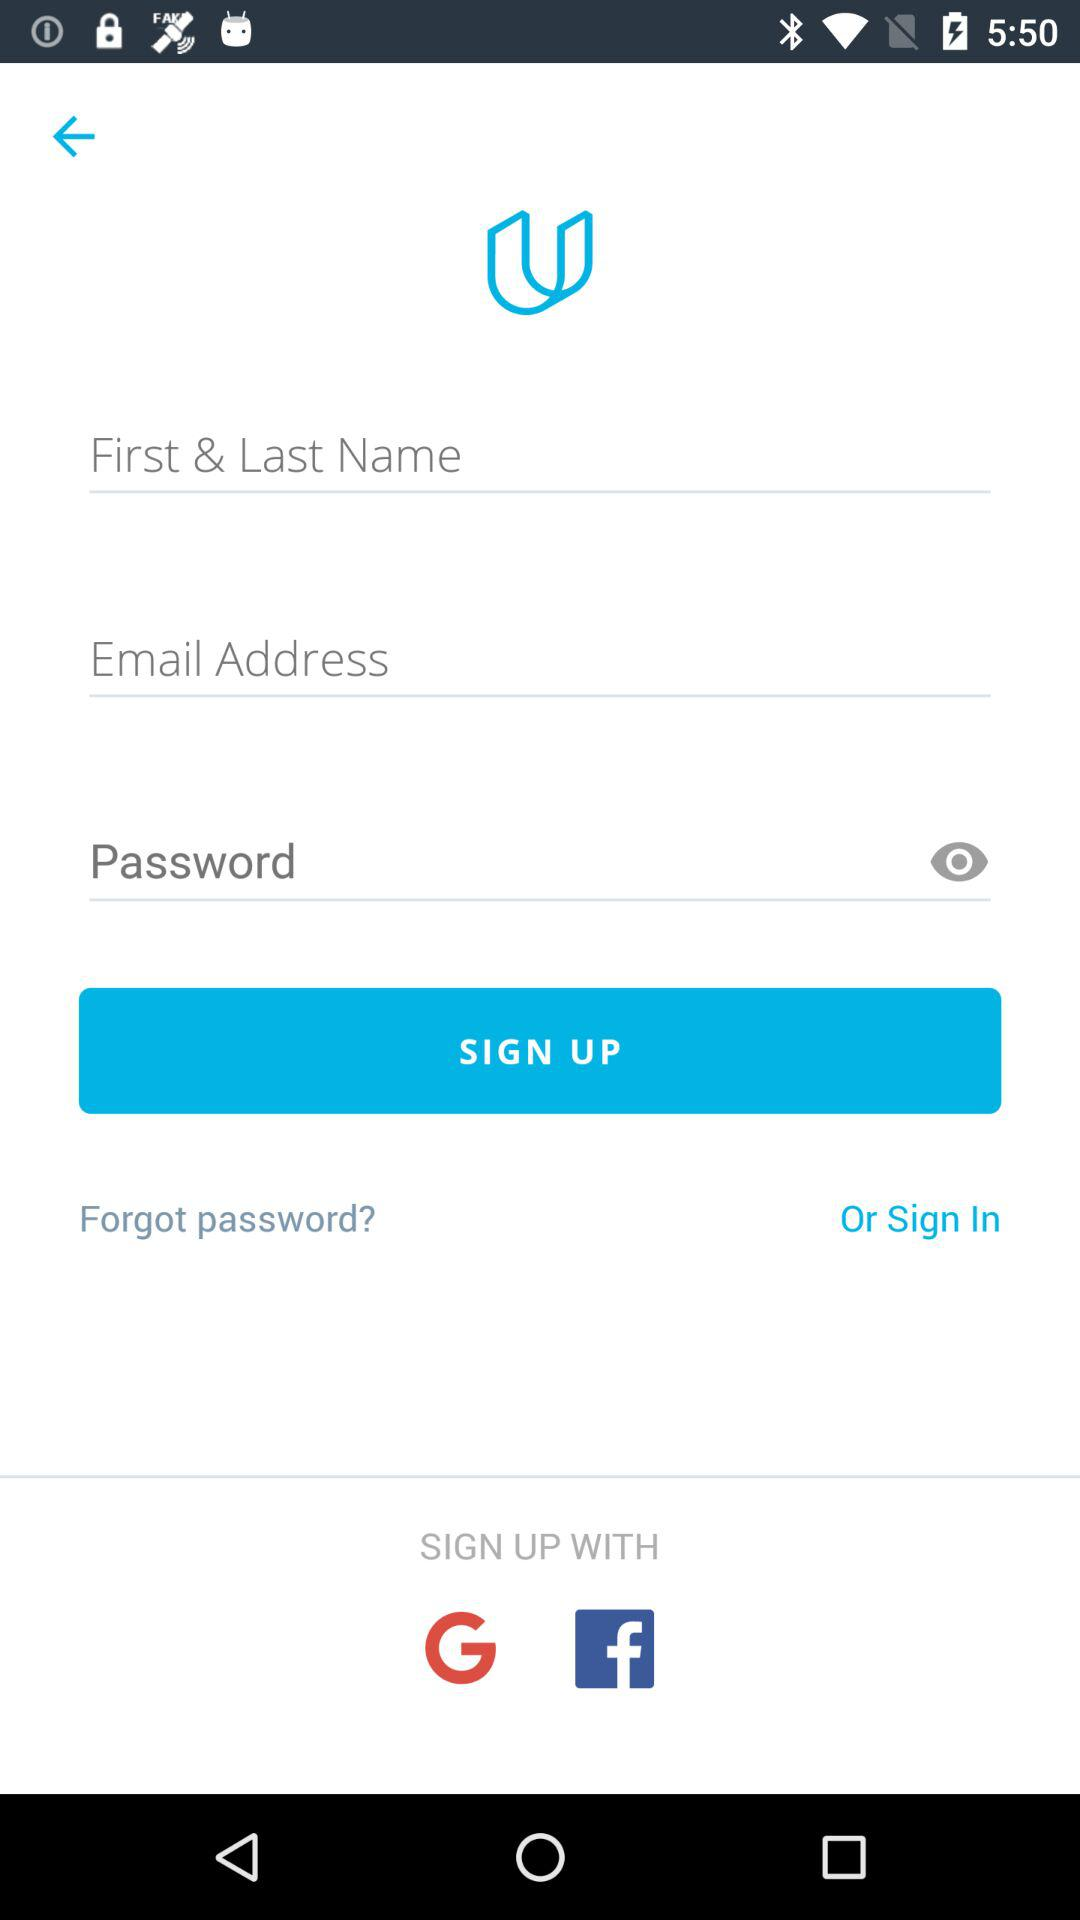How many text inputs are required to sign up?
Answer the question using a single word or phrase. 3 